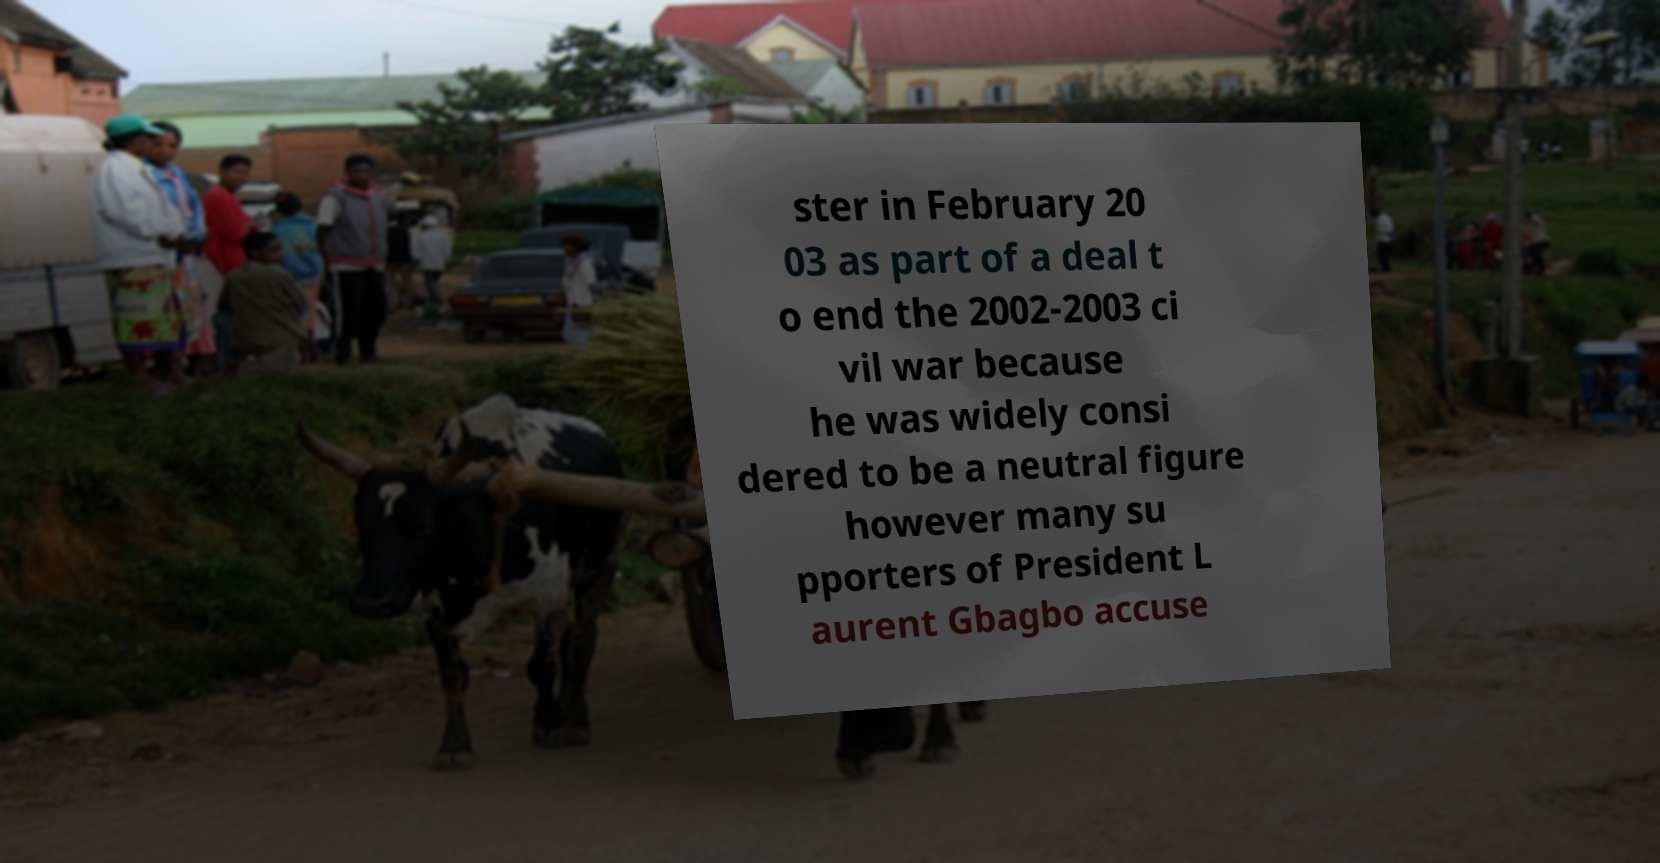Could you extract and type out the text from this image? ster in February 20 03 as part of a deal t o end the 2002-2003 ci vil war because he was widely consi dered to be a neutral figure however many su pporters of President L aurent Gbagbo accuse 